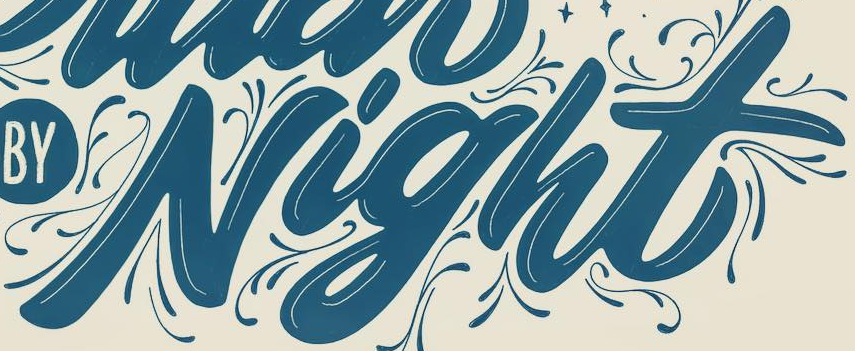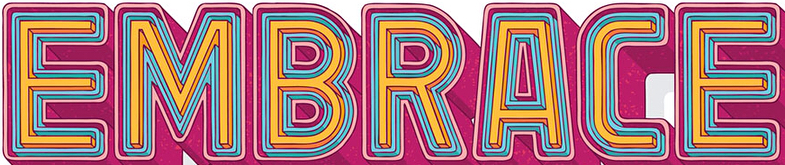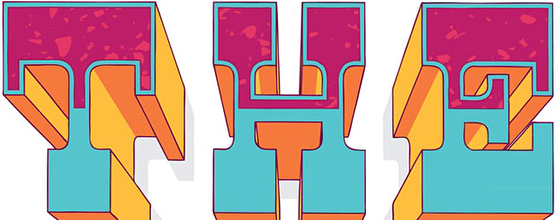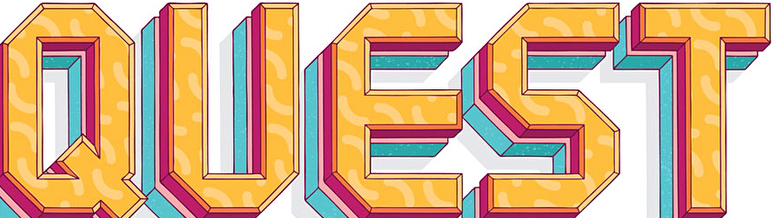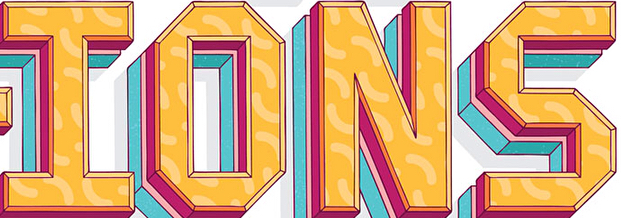What text is displayed in these images sequentially, separated by a semicolon? Night; EMBRACE; THE; QUEST; IONS 